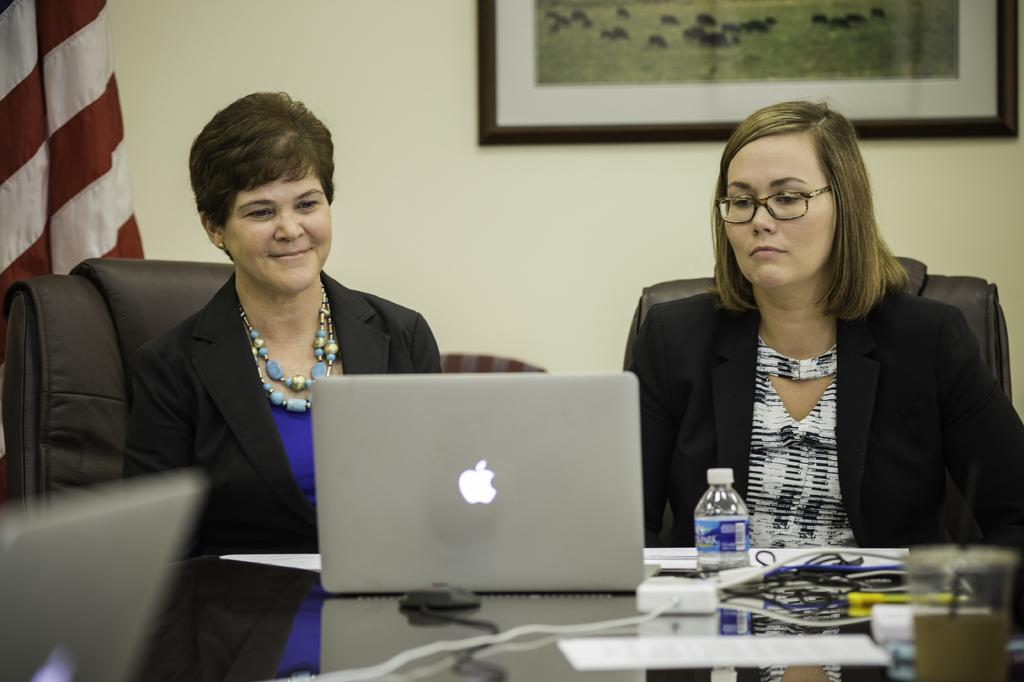How many people are in the image? There are two people in the image. What are the people doing in the image? The people are sitting in front of a table. What can be seen on the table? The table contains laptops, a water bottle, and other objects. What is visible behind the people? There is a photo frame and a flag behind the people. What type of dinosaurs can be seen in the image? There are no dinosaurs present in the image. Can you hear the people talking in the image? The image is a still picture, so we cannot hear any sounds or conversations. 